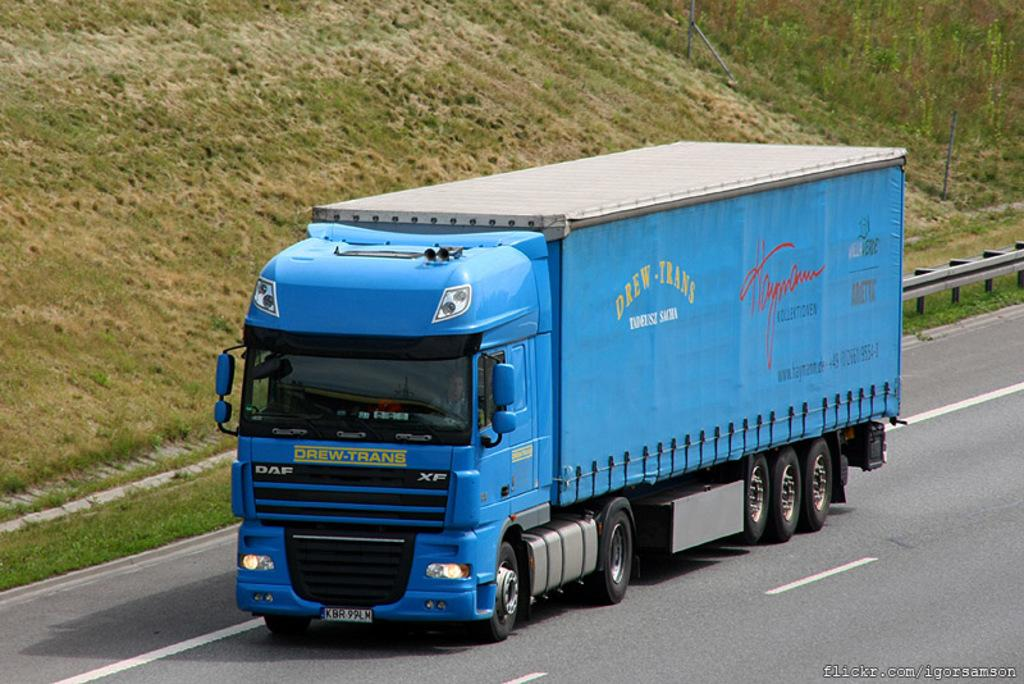What type of vehicle is in the image? There is a blue color truck in the image. What is the truck doing in the image? The truck is moving on a road. What can be seen in the background of the image? There are plants and grass visible in the background of the image. What type of canvas is the woman painting in the image? There is no woman or canvas present in the image; it features a blue color truck moving on a road with plants and grass in the background. 